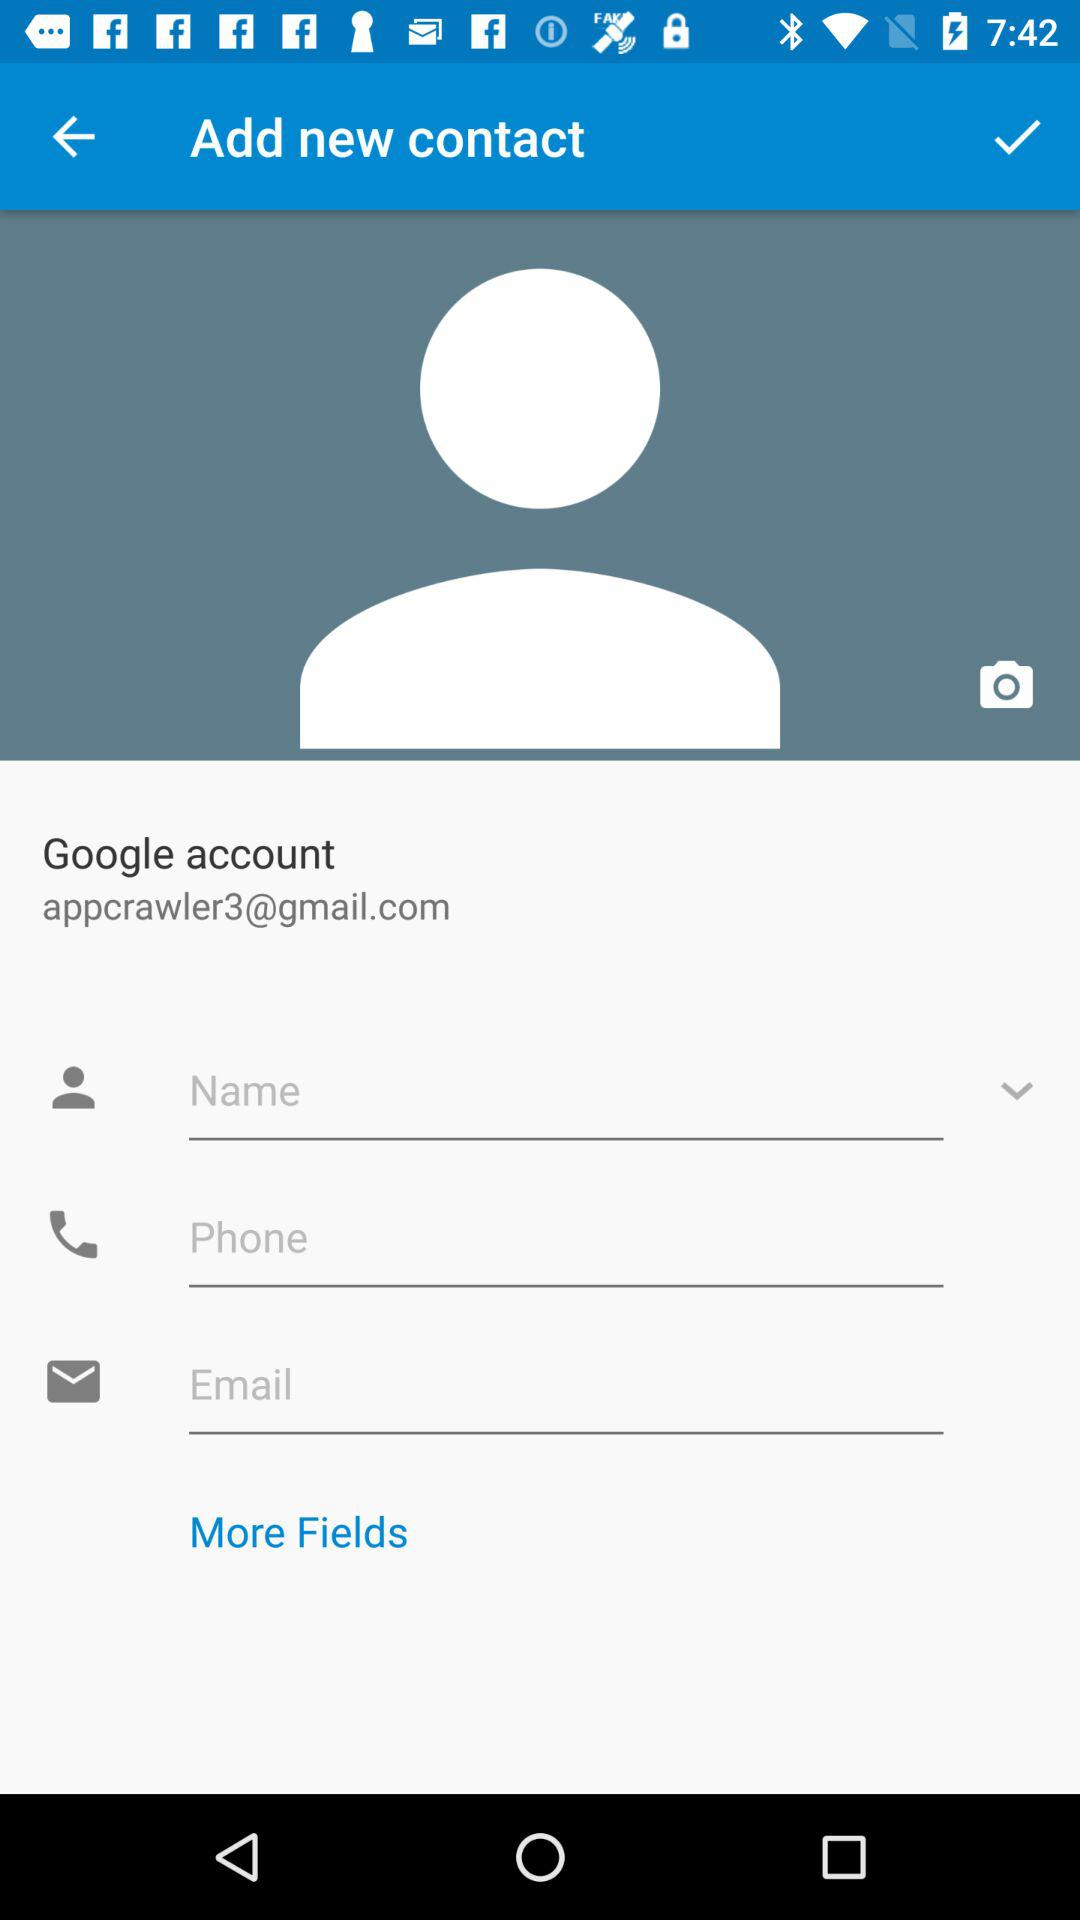What is the email address of the user? The email address of the user is appcrawler3@gmail.com. 